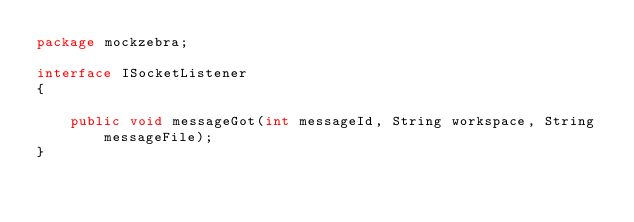Convert code to text. <code><loc_0><loc_0><loc_500><loc_500><_Java_>package mockzebra;

interface ISocketListener
{

    public void messageGot(int messageId, String workspace, String messageFile);
}
</code> 